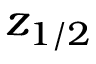<formula> <loc_0><loc_0><loc_500><loc_500>z _ { 1 / 2 }</formula> 